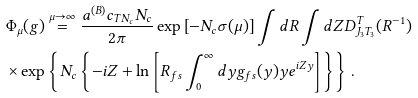Convert formula to latex. <formula><loc_0><loc_0><loc_500><loc_500>& \Phi _ { \mu } ( g ) \overset { \mu \rightarrow \infty } { = } \frac { a ^ { ( B ) } c _ { T N _ { c } } N _ { c } } { 2 \pi } \exp \left [ - N _ { c } \sigma ( \mu ) \right ] \int d R \int d Z D _ { J _ { 3 } T _ { 3 } } ^ { T } ( R ^ { - 1 } ) \\ & \times \exp \left \{ N _ { c } \left \{ - i Z + \ln \left [ R _ { f s } \int _ { 0 } ^ { \infty } d y g _ { f s } ( y ) y e ^ { i Z y } \right ] \right \} \right \} \, .</formula> 